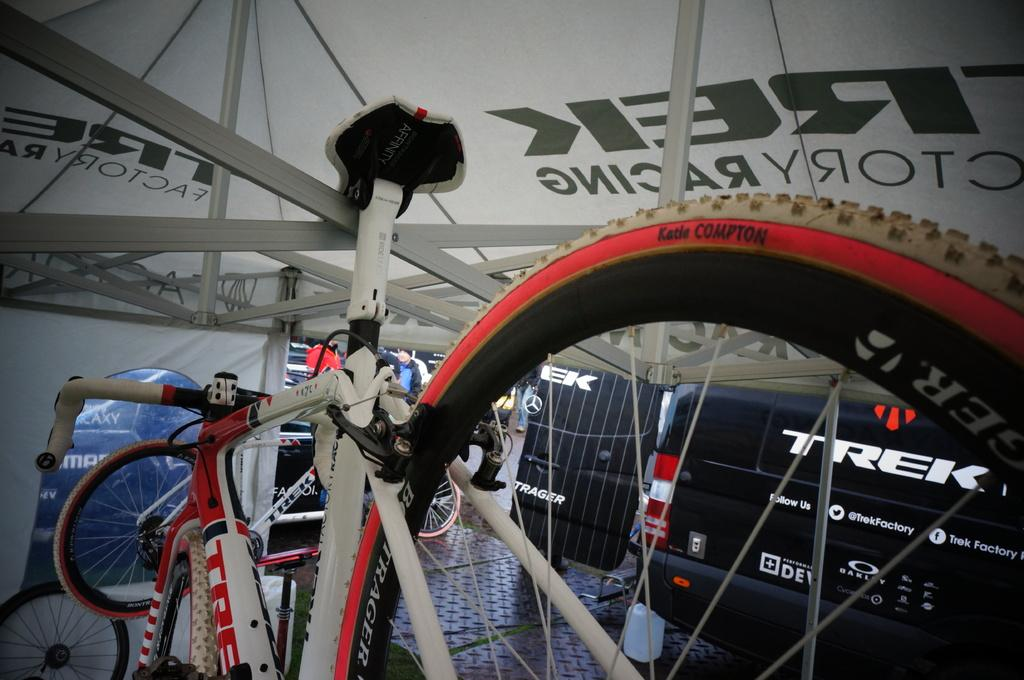What type of vehicles are in the image? There are bicycles in the image. What else can be seen in the image besides the bicycles? There is an object with text written on it and a roof with metal rods associated with it. What type of soda is being advertised on the actor's shirt in the image? There is no actor or soda present in the image; it features bicycles, an object with text, and a roof with metal rods. 